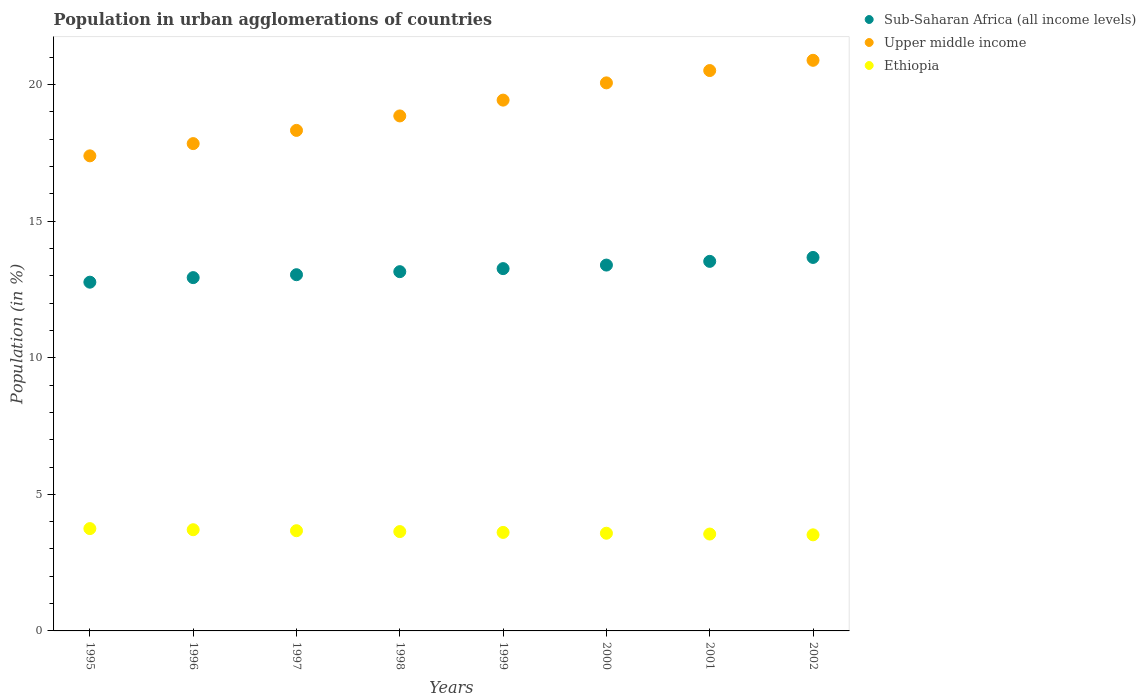What is the percentage of population in urban agglomerations in Ethiopia in 1996?
Make the answer very short. 3.71. Across all years, what is the maximum percentage of population in urban agglomerations in Sub-Saharan Africa (all income levels)?
Give a very brief answer. 13.67. Across all years, what is the minimum percentage of population in urban agglomerations in Ethiopia?
Ensure brevity in your answer.  3.52. In which year was the percentage of population in urban agglomerations in Ethiopia maximum?
Provide a short and direct response. 1995. What is the total percentage of population in urban agglomerations in Ethiopia in the graph?
Give a very brief answer. 29.01. What is the difference between the percentage of population in urban agglomerations in Upper middle income in 1996 and that in 1998?
Offer a very short reply. -1.01. What is the difference between the percentage of population in urban agglomerations in Sub-Saharan Africa (all income levels) in 1995 and the percentage of population in urban agglomerations in Ethiopia in 2001?
Give a very brief answer. 9.22. What is the average percentage of population in urban agglomerations in Sub-Saharan Africa (all income levels) per year?
Your response must be concise. 13.22. In the year 2000, what is the difference between the percentage of population in urban agglomerations in Ethiopia and percentage of population in urban agglomerations in Upper middle income?
Give a very brief answer. -16.49. In how many years, is the percentage of population in urban agglomerations in Ethiopia greater than 14 %?
Keep it short and to the point. 0. What is the ratio of the percentage of population in urban agglomerations in Upper middle income in 1995 to that in 2000?
Make the answer very short. 0.87. Is the difference between the percentage of population in urban agglomerations in Ethiopia in 1995 and 1999 greater than the difference between the percentage of population in urban agglomerations in Upper middle income in 1995 and 1999?
Ensure brevity in your answer.  Yes. What is the difference between the highest and the second highest percentage of population in urban agglomerations in Sub-Saharan Africa (all income levels)?
Make the answer very short. 0.14. What is the difference between the highest and the lowest percentage of population in urban agglomerations in Ethiopia?
Offer a terse response. 0.23. Is the sum of the percentage of population in urban agglomerations in Ethiopia in 1998 and 2000 greater than the maximum percentage of population in urban agglomerations in Upper middle income across all years?
Keep it short and to the point. No. Is it the case that in every year, the sum of the percentage of population in urban agglomerations in Ethiopia and percentage of population in urban agglomerations in Sub-Saharan Africa (all income levels)  is greater than the percentage of population in urban agglomerations in Upper middle income?
Keep it short and to the point. No. Is the percentage of population in urban agglomerations in Ethiopia strictly less than the percentage of population in urban agglomerations in Sub-Saharan Africa (all income levels) over the years?
Your response must be concise. Yes. How many dotlines are there?
Your response must be concise. 3. What is the difference between two consecutive major ticks on the Y-axis?
Provide a succinct answer. 5. Are the values on the major ticks of Y-axis written in scientific E-notation?
Your answer should be very brief. No. Does the graph contain any zero values?
Offer a terse response. No. How many legend labels are there?
Offer a terse response. 3. How are the legend labels stacked?
Your response must be concise. Vertical. What is the title of the graph?
Provide a succinct answer. Population in urban agglomerations of countries. What is the label or title of the Y-axis?
Keep it short and to the point. Population (in %). What is the Population (in %) in Sub-Saharan Africa (all income levels) in 1995?
Give a very brief answer. 12.77. What is the Population (in %) of Upper middle income in 1995?
Your response must be concise. 17.39. What is the Population (in %) of Ethiopia in 1995?
Offer a terse response. 3.75. What is the Population (in %) of Sub-Saharan Africa (all income levels) in 1996?
Provide a succinct answer. 12.94. What is the Population (in %) in Upper middle income in 1996?
Ensure brevity in your answer.  17.84. What is the Population (in %) of Ethiopia in 1996?
Your response must be concise. 3.71. What is the Population (in %) of Sub-Saharan Africa (all income levels) in 1997?
Offer a terse response. 13.04. What is the Population (in %) of Upper middle income in 1997?
Offer a terse response. 18.33. What is the Population (in %) of Ethiopia in 1997?
Give a very brief answer. 3.67. What is the Population (in %) in Sub-Saharan Africa (all income levels) in 1998?
Keep it short and to the point. 13.15. What is the Population (in %) in Upper middle income in 1998?
Offer a very short reply. 18.86. What is the Population (in %) in Ethiopia in 1998?
Keep it short and to the point. 3.64. What is the Population (in %) in Sub-Saharan Africa (all income levels) in 1999?
Ensure brevity in your answer.  13.27. What is the Population (in %) of Upper middle income in 1999?
Offer a very short reply. 19.44. What is the Population (in %) in Ethiopia in 1999?
Offer a very short reply. 3.61. What is the Population (in %) of Sub-Saharan Africa (all income levels) in 2000?
Offer a terse response. 13.4. What is the Population (in %) of Upper middle income in 2000?
Make the answer very short. 20.07. What is the Population (in %) of Ethiopia in 2000?
Give a very brief answer. 3.58. What is the Population (in %) of Sub-Saharan Africa (all income levels) in 2001?
Offer a terse response. 13.53. What is the Population (in %) of Upper middle income in 2001?
Offer a very short reply. 20.52. What is the Population (in %) of Ethiopia in 2001?
Keep it short and to the point. 3.55. What is the Population (in %) in Sub-Saharan Africa (all income levels) in 2002?
Give a very brief answer. 13.67. What is the Population (in %) of Upper middle income in 2002?
Your response must be concise. 20.89. What is the Population (in %) in Ethiopia in 2002?
Ensure brevity in your answer.  3.52. Across all years, what is the maximum Population (in %) of Sub-Saharan Africa (all income levels)?
Your response must be concise. 13.67. Across all years, what is the maximum Population (in %) of Upper middle income?
Your answer should be very brief. 20.89. Across all years, what is the maximum Population (in %) in Ethiopia?
Make the answer very short. 3.75. Across all years, what is the minimum Population (in %) in Sub-Saharan Africa (all income levels)?
Ensure brevity in your answer.  12.77. Across all years, what is the minimum Population (in %) of Upper middle income?
Your answer should be very brief. 17.39. Across all years, what is the minimum Population (in %) of Ethiopia?
Offer a terse response. 3.52. What is the total Population (in %) in Sub-Saharan Africa (all income levels) in the graph?
Provide a short and direct response. 105.77. What is the total Population (in %) in Upper middle income in the graph?
Offer a very short reply. 153.33. What is the total Population (in %) in Ethiopia in the graph?
Provide a succinct answer. 29.01. What is the difference between the Population (in %) of Sub-Saharan Africa (all income levels) in 1995 and that in 1996?
Ensure brevity in your answer.  -0.17. What is the difference between the Population (in %) of Upper middle income in 1995 and that in 1996?
Offer a terse response. -0.45. What is the difference between the Population (in %) of Ethiopia in 1995 and that in 1996?
Provide a succinct answer. 0.04. What is the difference between the Population (in %) in Sub-Saharan Africa (all income levels) in 1995 and that in 1997?
Your answer should be compact. -0.27. What is the difference between the Population (in %) in Upper middle income in 1995 and that in 1997?
Make the answer very short. -0.93. What is the difference between the Population (in %) in Ethiopia in 1995 and that in 1997?
Ensure brevity in your answer.  0.08. What is the difference between the Population (in %) of Sub-Saharan Africa (all income levels) in 1995 and that in 1998?
Your response must be concise. -0.38. What is the difference between the Population (in %) of Upper middle income in 1995 and that in 1998?
Keep it short and to the point. -1.46. What is the difference between the Population (in %) of Ethiopia in 1995 and that in 1998?
Offer a very short reply. 0.11. What is the difference between the Population (in %) in Sub-Saharan Africa (all income levels) in 1995 and that in 1999?
Provide a short and direct response. -0.5. What is the difference between the Population (in %) in Upper middle income in 1995 and that in 1999?
Your response must be concise. -2.04. What is the difference between the Population (in %) in Ethiopia in 1995 and that in 1999?
Offer a very short reply. 0.14. What is the difference between the Population (in %) of Sub-Saharan Africa (all income levels) in 1995 and that in 2000?
Ensure brevity in your answer.  -0.63. What is the difference between the Population (in %) in Upper middle income in 1995 and that in 2000?
Provide a short and direct response. -2.67. What is the difference between the Population (in %) of Ethiopia in 1995 and that in 2000?
Your answer should be very brief. 0.17. What is the difference between the Population (in %) in Sub-Saharan Africa (all income levels) in 1995 and that in 2001?
Ensure brevity in your answer.  -0.76. What is the difference between the Population (in %) in Upper middle income in 1995 and that in 2001?
Your answer should be compact. -3.12. What is the difference between the Population (in %) in Ethiopia in 1995 and that in 2001?
Your response must be concise. 0.2. What is the difference between the Population (in %) of Sub-Saharan Africa (all income levels) in 1995 and that in 2002?
Ensure brevity in your answer.  -0.91. What is the difference between the Population (in %) of Upper middle income in 1995 and that in 2002?
Ensure brevity in your answer.  -3.5. What is the difference between the Population (in %) of Ethiopia in 1995 and that in 2002?
Offer a terse response. 0.23. What is the difference between the Population (in %) in Sub-Saharan Africa (all income levels) in 1996 and that in 1997?
Offer a terse response. -0.11. What is the difference between the Population (in %) in Upper middle income in 1996 and that in 1997?
Offer a terse response. -0.48. What is the difference between the Population (in %) of Ethiopia in 1996 and that in 1997?
Your answer should be compact. 0.04. What is the difference between the Population (in %) of Sub-Saharan Africa (all income levels) in 1996 and that in 1998?
Make the answer very short. -0.22. What is the difference between the Population (in %) of Upper middle income in 1996 and that in 1998?
Your answer should be compact. -1.01. What is the difference between the Population (in %) in Ethiopia in 1996 and that in 1998?
Make the answer very short. 0.07. What is the difference between the Population (in %) in Sub-Saharan Africa (all income levels) in 1996 and that in 1999?
Offer a terse response. -0.33. What is the difference between the Population (in %) of Upper middle income in 1996 and that in 1999?
Offer a terse response. -1.59. What is the difference between the Population (in %) of Ethiopia in 1996 and that in 1999?
Your answer should be compact. 0.1. What is the difference between the Population (in %) in Sub-Saharan Africa (all income levels) in 1996 and that in 2000?
Ensure brevity in your answer.  -0.46. What is the difference between the Population (in %) in Upper middle income in 1996 and that in 2000?
Make the answer very short. -2.22. What is the difference between the Population (in %) of Ethiopia in 1996 and that in 2000?
Your answer should be compact. 0.13. What is the difference between the Population (in %) of Sub-Saharan Africa (all income levels) in 1996 and that in 2001?
Your response must be concise. -0.6. What is the difference between the Population (in %) in Upper middle income in 1996 and that in 2001?
Your answer should be compact. -2.67. What is the difference between the Population (in %) in Ethiopia in 1996 and that in 2001?
Give a very brief answer. 0.16. What is the difference between the Population (in %) in Sub-Saharan Africa (all income levels) in 1996 and that in 2002?
Ensure brevity in your answer.  -0.74. What is the difference between the Population (in %) of Upper middle income in 1996 and that in 2002?
Ensure brevity in your answer.  -3.05. What is the difference between the Population (in %) in Ethiopia in 1996 and that in 2002?
Your response must be concise. 0.19. What is the difference between the Population (in %) in Sub-Saharan Africa (all income levels) in 1997 and that in 1998?
Your answer should be compact. -0.11. What is the difference between the Population (in %) in Upper middle income in 1997 and that in 1998?
Keep it short and to the point. -0.53. What is the difference between the Population (in %) of Ethiopia in 1997 and that in 1998?
Offer a very short reply. 0.03. What is the difference between the Population (in %) in Sub-Saharan Africa (all income levels) in 1997 and that in 1999?
Ensure brevity in your answer.  -0.22. What is the difference between the Population (in %) of Upper middle income in 1997 and that in 1999?
Make the answer very short. -1.11. What is the difference between the Population (in %) in Ethiopia in 1997 and that in 1999?
Ensure brevity in your answer.  0.06. What is the difference between the Population (in %) in Sub-Saharan Africa (all income levels) in 1997 and that in 2000?
Offer a very short reply. -0.35. What is the difference between the Population (in %) in Upper middle income in 1997 and that in 2000?
Your answer should be compact. -1.74. What is the difference between the Population (in %) of Ethiopia in 1997 and that in 2000?
Ensure brevity in your answer.  0.09. What is the difference between the Population (in %) in Sub-Saharan Africa (all income levels) in 1997 and that in 2001?
Offer a very short reply. -0.49. What is the difference between the Population (in %) of Upper middle income in 1997 and that in 2001?
Make the answer very short. -2.19. What is the difference between the Population (in %) of Ethiopia in 1997 and that in 2001?
Offer a very short reply. 0.12. What is the difference between the Population (in %) of Sub-Saharan Africa (all income levels) in 1997 and that in 2002?
Ensure brevity in your answer.  -0.63. What is the difference between the Population (in %) in Upper middle income in 1997 and that in 2002?
Offer a very short reply. -2.57. What is the difference between the Population (in %) in Ethiopia in 1997 and that in 2002?
Give a very brief answer. 0.15. What is the difference between the Population (in %) in Sub-Saharan Africa (all income levels) in 1998 and that in 1999?
Offer a terse response. -0.11. What is the difference between the Population (in %) of Upper middle income in 1998 and that in 1999?
Provide a short and direct response. -0.58. What is the difference between the Population (in %) in Ethiopia in 1998 and that in 1999?
Give a very brief answer. 0.03. What is the difference between the Population (in %) in Sub-Saharan Africa (all income levels) in 1998 and that in 2000?
Offer a terse response. -0.24. What is the difference between the Population (in %) of Upper middle income in 1998 and that in 2000?
Give a very brief answer. -1.21. What is the difference between the Population (in %) in Ethiopia in 1998 and that in 2000?
Provide a short and direct response. 0.06. What is the difference between the Population (in %) of Sub-Saharan Africa (all income levels) in 1998 and that in 2001?
Your response must be concise. -0.38. What is the difference between the Population (in %) in Upper middle income in 1998 and that in 2001?
Offer a terse response. -1.66. What is the difference between the Population (in %) of Ethiopia in 1998 and that in 2001?
Offer a terse response. 0.09. What is the difference between the Population (in %) of Sub-Saharan Africa (all income levels) in 1998 and that in 2002?
Give a very brief answer. -0.52. What is the difference between the Population (in %) of Upper middle income in 1998 and that in 2002?
Provide a short and direct response. -2.04. What is the difference between the Population (in %) of Ethiopia in 1998 and that in 2002?
Offer a very short reply. 0.12. What is the difference between the Population (in %) in Sub-Saharan Africa (all income levels) in 1999 and that in 2000?
Provide a short and direct response. -0.13. What is the difference between the Population (in %) in Upper middle income in 1999 and that in 2000?
Provide a short and direct response. -0.63. What is the difference between the Population (in %) of Ethiopia in 1999 and that in 2000?
Offer a very short reply. 0.03. What is the difference between the Population (in %) in Sub-Saharan Africa (all income levels) in 1999 and that in 2001?
Keep it short and to the point. -0.27. What is the difference between the Population (in %) in Upper middle income in 1999 and that in 2001?
Keep it short and to the point. -1.08. What is the difference between the Population (in %) of Ethiopia in 1999 and that in 2001?
Ensure brevity in your answer.  0.06. What is the difference between the Population (in %) of Sub-Saharan Africa (all income levels) in 1999 and that in 2002?
Keep it short and to the point. -0.41. What is the difference between the Population (in %) in Upper middle income in 1999 and that in 2002?
Your response must be concise. -1.46. What is the difference between the Population (in %) in Ethiopia in 1999 and that in 2002?
Give a very brief answer. 0.09. What is the difference between the Population (in %) of Sub-Saharan Africa (all income levels) in 2000 and that in 2001?
Your response must be concise. -0.14. What is the difference between the Population (in %) in Upper middle income in 2000 and that in 2001?
Provide a short and direct response. -0.45. What is the difference between the Population (in %) in Ethiopia in 2000 and that in 2001?
Ensure brevity in your answer.  0.03. What is the difference between the Population (in %) of Sub-Saharan Africa (all income levels) in 2000 and that in 2002?
Your response must be concise. -0.28. What is the difference between the Population (in %) in Upper middle income in 2000 and that in 2002?
Your answer should be very brief. -0.83. What is the difference between the Population (in %) of Ethiopia in 2000 and that in 2002?
Offer a terse response. 0.06. What is the difference between the Population (in %) of Sub-Saharan Africa (all income levels) in 2001 and that in 2002?
Give a very brief answer. -0.14. What is the difference between the Population (in %) in Upper middle income in 2001 and that in 2002?
Offer a terse response. -0.38. What is the difference between the Population (in %) of Ethiopia in 2001 and that in 2002?
Make the answer very short. 0.03. What is the difference between the Population (in %) in Sub-Saharan Africa (all income levels) in 1995 and the Population (in %) in Upper middle income in 1996?
Make the answer very short. -5.07. What is the difference between the Population (in %) of Sub-Saharan Africa (all income levels) in 1995 and the Population (in %) of Ethiopia in 1996?
Your answer should be very brief. 9.06. What is the difference between the Population (in %) in Upper middle income in 1995 and the Population (in %) in Ethiopia in 1996?
Offer a terse response. 13.69. What is the difference between the Population (in %) of Sub-Saharan Africa (all income levels) in 1995 and the Population (in %) of Upper middle income in 1997?
Your response must be concise. -5.56. What is the difference between the Population (in %) of Sub-Saharan Africa (all income levels) in 1995 and the Population (in %) of Ethiopia in 1997?
Ensure brevity in your answer.  9.1. What is the difference between the Population (in %) in Upper middle income in 1995 and the Population (in %) in Ethiopia in 1997?
Give a very brief answer. 13.73. What is the difference between the Population (in %) of Sub-Saharan Africa (all income levels) in 1995 and the Population (in %) of Upper middle income in 1998?
Your answer should be very brief. -6.09. What is the difference between the Population (in %) in Sub-Saharan Africa (all income levels) in 1995 and the Population (in %) in Ethiopia in 1998?
Make the answer very short. 9.13. What is the difference between the Population (in %) of Upper middle income in 1995 and the Population (in %) of Ethiopia in 1998?
Your answer should be compact. 13.76. What is the difference between the Population (in %) of Sub-Saharan Africa (all income levels) in 1995 and the Population (in %) of Upper middle income in 1999?
Your answer should be compact. -6.67. What is the difference between the Population (in %) in Sub-Saharan Africa (all income levels) in 1995 and the Population (in %) in Ethiopia in 1999?
Give a very brief answer. 9.16. What is the difference between the Population (in %) in Upper middle income in 1995 and the Population (in %) in Ethiopia in 1999?
Provide a succinct answer. 13.79. What is the difference between the Population (in %) in Sub-Saharan Africa (all income levels) in 1995 and the Population (in %) in Upper middle income in 2000?
Keep it short and to the point. -7.3. What is the difference between the Population (in %) of Sub-Saharan Africa (all income levels) in 1995 and the Population (in %) of Ethiopia in 2000?
Give a very brief answer. 9.19. What is the difference between the Population (in %) of Upper middle income in 1995 and the Population (in %) of Ethiopia in 2000?
Your answer should be very brief. 13.82. What is the difference between the Population (in %) in Sub-Saharan Africa (all income levels) in 1995 and the Population (in %) in Upper middle income in 2001?
Your answer should be compact. -7.75. What is the difference between the Population (in %) of Sub-Saharan Africa (all income levels) in 1995 and the Population (in %) of Ethiopia in 2001?
Keep it short and to the point. 9.22. What is the difference between the Population (in %) in Upper middle income in 1995 and the Population (in %) in Ethiopia in 2001?
Make the answer very short. 13.85. What is the difference between the Population (in %) of Sub-Saharan Africa (all income levels) in 1995 and the Population (in %) of Upper middle income in 2002?
Give a very brief answer. -8.12. What is the difference between the Population (in %) in Sub-Saharan Africa (all income levels) in 1995 and the Population (in %) in Ethiopia in 2002?
Your response must be concise. 9.25. What is the difference between the Population (in %) of Upper middle income in 1995 and the Population (in %) of Ethiopia in 2002?
Keep it short and to the point. 13.88. What is the difference between the Population (in %) of Sub-Saharan Africa (all income levels) in 1996 and the Population (in %) of Upper middle income in 1997?
Your answer should be compact. -5.39. What is the difference between the Population (in %) in Sub-Saharan Africa (all income levels) in 1996 and the Population (in %) in Ethiopia in 1997?
Offer a very short reply. 9.27. What is the difference between the Population (in %) in Upper middle income in 1996 and the Population (in %) in Ethiopia in 1997?
Keep it short and to the point. 14.17. What is the difference between the Population (in %) in Sub-Saharan Africa (all income levels) in 1996 and the Population (in %) in Upper middle income in 1998?
Your answer should be compact. -5.92. What is the difference between the Population (in %) of Sub-Saharan Africa (all income levels) in 1996 and the Population (in %) of Ethiopia in 1998?
Give a very brief answer. 9.3. What is the difference between the Population (in %) in Upper middle income in 1996 and the Population (in %) in Ethiopia in 1998?
Your response must be concise. 14.21. What is the difference between the Population (in %) of Sub-Saharan Africa (all income levels) in 1996 and the Population (in %) of Upper middle income in 1999?
Provide a succinct answer. -6.5. What is the difference between the Population (in %) in Sub-Saharan Africa (all income levels) in 1996 and the Population (in %) in Ethiopia in 1999?
Give a very brief answer. 9.33. What is the difference between the Population (in %) in Upper middle income in 1996 and the Population (in %) in Ethiopia in 1999?
Provide a short and direct response. 14.24. What is the difference between the Population (in %) in Sub-Saharan Africa (all income levels) in 1996 and the Population (in %) in Upper middle income in 2000?
Keep it short and to the point. -7.13. What is the difference between the Population (in %) in Sub-Saharan Africa (all income levels) in 1996 and the Population (in %) in Ethiopia in 2000?
Make the answer very short. 9.36. What is the difference between the Population (in %) in Upper middle income in 1996 and the Population (in %) in Ethiopia in 2000?
Provide a succinct answer. 14.27. What is the difference between the Population (in %) in Sub-Saharan Africa (all income levels) in 1996 and the Population (in %) in Upper middle income in 2001?
Offer a very short reply. -7.58. What is the difference between the Population (in %) of Sub-Saharan Africa (all income levels) in 1996 and the Population (in %) of Ethiopia in 2001?
Offer a very short reply. 9.39. What is the difference between the Population (in %) of Upper middle income in 1996 and the Population (in %) of Ethiopia in 2001?
Give a very brief answer. 14.3. What is the difference between the Population (in %) in Sub-Saharan Africa (all income levels) in 1996 and the Population (in %) in Upper middle income in 2002?
Offer a very short reply. -7.96. What is the difference between the Population (in %) in Sub-Saharan Africa (all income levels) in 1996 and the Population (in %) in Ethiopia in 2002?
Provide a short and direct response. 9.42. What is the difference between the Population (in %) of Upper middle income in 1996 and the Population (in %) of Ethiopia in 2002?
Keep it short and to the point. 14.32. What is the difference between the Population (in %) of Sub-Saharan Africa (all income levels) in 1997 and the Population (in %) of Upper middle income in 1998?
Make the answer very short. -5.81. What is the difference between the Population (in %) in Sub-Saharan Africa (all income levels) in 1997 and the Population (in %) in Ethiopia in 1998?
Offer a very short reply. 9.41. What is the difference between the Population (in %) in Upper middle income in 1997 and the Population (in %) in Ethiopia in 1998?
Ensure brevity in your answer.  14.69. What is the difference between the Population (in %) of Sub-Saharan Africa (all income levels) in 1997 and the Population (in %) of Upper middle income in 1999?
Provide a succinct answer. -6.39. What is the difference between the Population (in %) of Sub-Saharan Africa (all income levels) in 1997 and the Population (in %) of Ethiopia in 1999?
Offer a very short reply. 9.44. What is the difference between the Population (in %) of Upper middle income in 1997 and the Population (in %) of Ethiopia in 1999?
Ensure brevity in your answer.  14.72. What is the difference between the Population (in %) of Sub-Saharan Africa (all income levels) in 1997 and the Population (in %) of Upper middle income in 2000?
Your answer should be very brief. -7.02. What is the difference between the Population (in %) in Sub-Saharan Africa (all income levels) in 1997 and the Population (in %) in Ethiopia in 2000?
Offer a terse response. 9.47. What is the difference between the Population (in %) in Upper middle income in 1997 and the Population (in %) in Ethiopia in 2000?
Provide a succinct answer. 14.75. What is the difference between the Population (in %) in Sub-Saharan Africa (all income levels) in 1997 and the Population (in %) in Upper middle income in 2001?
Your answer should be compact. -7.48. What is the difference between the Population (in %) in Sub-Saharan Africa (all income levels) in 1997 and the Population (in %) in Ethiopia in 2001?
Offer a terse response. 9.5. What is the difference between the Population (in %) of Upper middle income in 1997 and the Population (in %) of Ethiopia in 2001?
Ensure brevity in your answer.  14.78. What is the difference between the Population (in %) in Sub-Saharan Africa (all income levels) in 1997 and the Population (in %) in Upper middle income in 2002?
Provide a succinct answer. -7.85. What is the difference between the Population (in %) of Sub-Saharan Africa (all income levels) in 1997 and the Population (in %) of Ethiopia in 2002?
Provide a short and direct response. 9.52. What is the difference between the Population (in %) of Upper middle income in 1997 and the Population (in %) of Ethiopia in 2002?
Keep it short and to the point. 14.81. What is the difference between the Population (in %) in Sub-Saharan Africa (all income levels) in 1998 and the Population (in %) in Upper middle income in 1999?
Keep it short and to the point. -6.28. What is the difference between the Population (in %) in Sub-Saharan Africa (all income levels) in 1998 and the Population (in %) in Ethiopia in 1999?
Provide a succinct answer. 9.55. What is the difference between the Population (in %) of Upper middle income in 1998 and the Population (in %) of Ethiopia in 1999?
Make the answer very short. 15.25. What is the difference between the Population (in %) of Sub-Saharan Africa (all income levels) in 1998 and the Population (in %) of Upper middle income in 2000?
Your response must be concise. -6.91. What is the difference between the Population (in %) in Sub-Saharan Africa (all income levels) in 1998 and the Population (in %) in Ethiopia in 2000?
Your answer should be very brief. 9.58. What is the difference between the Population (in %) in Upper middle income in 1998 and the Population (in %) in Ethiopia in 2000?
Offer a very short reply. 15.28. What is the difference between the Population (in %) in Sub-Saharan Africa (all income levels) in 1998 and the Population (in %) in Upper middle income in 2001?
Make the answer very short. -7.36. What is the difference between the Population (in %) in Sub-Saharan Africa (all income levels) in 1998 and the Population (in %) in Ethiopia in 2001?
Make the answer very short. 9.61. What is the difference between the Population (in %) in Upper middle income in 1998 and the Population (in %) in Ethiopia in 2001?
Make the answer very short. 15.31. What is the difference between the Population (in %) in Sub-Saharan Africa (all income levels) in 1998 and the Population (in %) in Upper middle income in 2002?
Your answer should be compact. -7.74. What is the difference between the Population (in %) in Sub-Saharan Africa (all income levels) in 1998 and the Population (in %) in Ethiopia in 2002?
Your answer should be compact. 9.64. What is the difference between the Population (in %) of Upper middle income in 1998 and the Population (in %) of Ethiopia in 2002?
Your response must be concise. 15.34. What is the difference between the Population (in %) in Sub-Saharan Africa (all income levels) in 1999 and the Population (in %) in Upper middle income in 2000?
Ensure brevity in your answer.  -6.8. What is the difference between the Population (in %) of Sub-Saharan Africa (all income levels) in 1999 and the Population (in %) of Ethiopia in 2000?
Make the answer very short. 9.69. What is the difference between the Population (in %) in Upper middle income in 1999 and the Population (in %) in Ethiopia in 2000?
Your response must be concise. 15.86. What is the difference between the Population (in %) in Sub-Saharan Africa (all income levels) in 1999 and the Population (in %) in Upper middle income in 2001?
Offer a very short reply. -7.25. What is the difference between the Population (in %) of Sub-Saharan Africa (all income levels) in 1999 and the Population (in %) of Ethiopia in 2001?
Your response must be concise. 9.72. What is the difference between the Population (in %) of Upper middle income in 1999 and the Population (in %) of Ethiopia in 2001?
Ensure brevity in your answer.  15.89. What is the difference between the Population (in %) of Sub-Saharan Africa (all income levels) in 1999 and the Population (in %) of Upper middle income in 2002?
Your answer should be very brief. -7.63. What is the difference between the Population (in %) in Sub-Saharan Africa (all income levels) in 1999 and the Population (in %) in Ethiopia in 2002?
Provide a short and direct response. 9.75. What is the difference between the Population (in %) of Upper middle income in 1999 and the Population (in %) of Ethiopia in 2002?
Provide a short and direct response. 15.92. What is the difference between the Population (in %) of Sub-Saharan Africa (all income levels) in 2000 and the Population (in %) of Upper middle income in 2001?
Your answer should be very brief. -7.12. What is the difference between the Population (in %) of Sub-Saharan Africa (all income levels) in 2000 and the Population (in %) of Ethiopia in 2001?
Offer a very short reply. 9.85. What is the difference between the Population (in %) in Upper middle income in 2000 and the Population (in %) in Ethiopia in 2001?
Keep it short and to the point. 16.52. What is the difference between the Population (in %) in Sub-Saharan Africa (all income levels) in 2000 and the Population (in %) in Upper middle income in 2002?
Provide a succinct answer. -7.5. What is the difference between the Population (in %) in Sub-Saharan Africa (all income levels) in 2000 and the Population (in %) in Ethiopia in 2002?
Provide a short and direct response. 9.88. What is the difference between the Population (in %) of Upper middle income in 2000 and the Population (in %) of Ethiopia in 2002?
Offer a terse response. 16.55. What is the difference between the Population (in %) of Sub-Saharan Africa (all income levels) in 2001 and the Population (in %) of Upper middle income in 2002?
Your answer should be very brief. -7.36. What is the difference between the Population (in %) of Sub-Saharan Africa (all income levels) in 2001 and the Population (in %) of Ethiopia in 2002?
Your response must be concise. 10.01. What is the difference between the Population (in %) of Upper middle income in 2001 and the Population (in %) of Ethiopia in 2002?
Offer a very short reply. 17. What is the average Population (in %) of Sub-Saharan Africa (all income levels) per year?
Offer a very short reply. 13.22. What is the average Population (in %) of Upper middle income per year?
Ensure brevity in your answer.  19.17. What is the average Population (in %) of Ethiopia per year?
Ensure brevity in your answer.  3.63. In the year 1995, what is the difference between the Population (in %) in Sub-Saharan Africa (all income levels) and Population (in %) in Upper middle income?
Your answer should be compact. -4.63. In the year 1995, what is the difference between the Population (in %) of Sub-Saharan Africa (all income levels) and Population (in %) of Ethiopia?
Make the answer very short. 9.02. In the year 1995, what is the difference between the Population (in %) of Upper middle income and Population (in %) of Ethiopia?
Keep it short and to the point. 13.65. In the year 1996, what is the difference between the Population (in %) of Sub-Saharan Africa (all income levels) and Population (in %) of Upper middle income?
Your answer should be compact. -4.91. In the year 1996, what is the difference between the Population (in %) in Sub-Saharan Africa (all income levels) and Population (in %) in Ethiopia?
Keep it short and to the point. 9.23. In the year 1996, what is the difference between the Population (in %) of Upper middle income and Population (in %) of Ethiopia?
Give a very brief answer. 14.14. In the year 1997, what is the difference between the Population (in %) in Sub-Saharan Africa (all income levels) and Population (in %) in Upper middle income?
Provide a short and direct response. -5.28. In the year 1997, what is the difference between the Population (in %) of Sub-Saharan Africa (all income levels) and Population (in %) of Ethiopia?
Your response must be concise. 9.37. In the year 1997, what is the difference between the Population (in %) in Upper middle income and Population (in %) in Ethiopia?
Make the answer very short. 14.66. In the year 1998, what is the difference between the Population (in %) of Sub-Saharan Africa (all income levels) and Population (in %) of Upper middle income?
Offer a very short reply. -5.7. In the year 1998, what is the difference between the Population (in %) of Sub-Saharan Africa (all income levels) and Population (in %) of Ethiopia?
Your answer should be compact. 9.52. In the year 1998, what is the difference between the Population (in %) in Upper middle income and Population (in %) in Ethiopia?
Provide a short and direct response. 15.22. In the year 1999, what is the difference between the Population (in %) in Sub-Saharan Africa (all income levels) and Population (in %) in Upper middle income?
Your answer should be very brief. -6.17. In the year 1999, what is the difference between the Population (in %) in Sub-Saharan Africa (all income levels) and Population (in %) in Ethiopia?
Give a very brief answer. 9.66. In the year 1999, what is the difference between the Population (in %) in Upper middle income and Population (in %) in Ethiopia?
Your answer should be very brief. 15.83. In the year 2000, what is the difference between the Population (in %) of Sub-Saharan Africa (all income levels) and Population (in %) of Upper middle income?
Keep it short and to the point. -6.67. In the year 2000, what is the difference between the Population (in %) of Sub-Saharan Africa (all income levels) and Population (in %) of Ethiopia?
Your response must be concise. 9.82. In the year 2000, what is the difference between the Population (in %) in Upper middle income and Population (in %) in Ethiopia?
Your response must be concise. 16.49. In the year 2001, what is the difference between the Population (in %) of Sub-Saharan Africa (all income levels) and Population (in %) of Upper middle income?
Offer a very short reply. -6.99. In the year 2001, what is the difference between the Population (in %) in Sub-Saharan Africa (all income levels) and Population (in %) in Ethiopia?
Ensure brevity in your answer.  9.98. In the year 2001, what is the difference between the Population (in %) in Upper middle income and Population (in %) in Ethiopia?
Make the answer very short. 16.97. In the year 2002, what is the difference between the Population (in %) in Sub-Saharan Africa (all income levels) and Population (in %) in Upper middle income?
Make the answer very short. -7.22. In the year 2002, what is the difference between the Population (in %) in Sub-Saharan Africa (all income levels) and Population (in %) in Ethiopia?
Ensure brevity in your answer.  10.16. In the year 2002, what is the difference between the Population (in %) in Upper middle income and Population (in %) in Ethiopia?
Ensure brevity in your answer.  17.37. What is the ratio of the Population (in %) of Sub-Saharan Africa (all income levels) in 1995 to that in 1996?
Your answer should be very brief. 0.99. What is the ratio of the Population (in %) of Upper middle income in 1995 to that in 1996?
Your answer should be very brief. 0.97. What is the ratio of the Population (in %) in Ethiopia in 1995 to that in 1996?
Provide a short and direct response. 1.01. What is the ratio of the Population (in %) of Upper middle income in 1995 to that in 1997?
Give a very brief answer. 0.95. What is the ratio of the Population (in %) in Sub-Saharan Africa (all income levels) in 1995 to that in 1998?
Your answer should be very brief. 0.97. What is the ratio of the Population (in %) of Upper middle income in 1995 to that in 1998?
Provide a succinct answer. 0.92. What is the ratio of the Population (in %) of Sub-Saharan Africa (all income levels) in 1995 to that in 1999?
Your answer should be compact. 0.96. What is the ratio of the Population (in %) of Upper middle income in 1995 to that in 1999?
Your answer should be compact. 0.9. What is the ratio of the Population (in %) in Ethiopia in 1995 to that in 1999?
Provide a short and direct response. 1.04. What is the ratio of the Population (in %) of Sub-Saharan Africa (all income levels) in 1995 to that in 2000?
Keep it short and to the point. 0.95. What is the ratio of the Population (in %) in Upper middle income in 1995 to that in 2000?
Ensure brevity in your answer.  0.87. What is the ratio of the Population (in %) of Ethiopia in 1995 to that in 2000?
Ensure brevity in your answer.  1.05. What is the ratio of the Population (in %) in Sub-Saharan Africa (all income levels) in 1995 to that in 2001?
Ensure brevity in your answer.  0.94. What is the ratio of the Population (in %) of Upper middle income in 1995 to that in 2001?
Your response must be concise. 0.85. What is the ratio of the Population (in %) of Ethiopia in 1995 to that in 2001?
Provide a succinct answer. 1.06. What is the ratio of the Population (in %) of Sub-Saharan Africa (all income levels) in 1995 to that in 2002?
Make the answer very short. 0.93. What is the ratio of the Population (in %) of Upper middle income in 1995 to that in 2002?
Provide a short and direct response. 0.83. What is the ratio of the Population (in %) of Ethiopia in 1995 to that in 2002?
Give a very brief answer. 1.06. What is the ratio of the Population (in %) of Upper middle income in 1996 to that in 1997?
Provide a short and direct response. 0.97. What is the ratio of the Population (in %) in Ethiopia in 1996 to that in 1997?
Make the answer very short. 1.01. What is the ratio of the Population (in %) in Sub-Saharan Africa (all income levels) in 1996 to that in 1998?
Provide a short and direct response. 0.98. What is the ratio of the Population (in %) in Upper middle income in 1996 to that in 1998?
Offer a very short reply. 0.95. What is the ratio of the Population (in %) in Ethiopia in 1996 to that in 1998?
Give a very brief answer. 1.02. What is the ratio of the Population (in %) of Sub-Saharan Africa (all income levels) in 1996 to that in 1999?
Your answer should be very brief. 0.98. What is the ratio of the Population (in %) of Upper middle income in 1996 to that in 1999?
Provide a succinct answer. 0.92. What is the ratio of the Population (in %) of Ethiopia in 1996 to that in 1999?
Your response must be concise. 1.03. What is the ratio of the Population (in %) of Sub-Saharan Africa (all income levels) in 1996 to that in 2000?
Provide a succinct answer. 0.97. What is the ratio of the Population (in %) of Upper middle income in 1996 to that in 2000?
Your response must be concise. 0.89. What is the ratio of the Population (in %) of Ethiopia in 1996 to that in 2000?
Keep it short and to the point. 1.04. What is the ratio of the Population (in %) of Sub-Saharan Africa (all income levels) in 1996 to that in 2001?
Your answer should be compact. 0.96. What is the ratio of the Population (in %) of Upper middle income in 1996 to that in 2001?
Your response must be concise. 0.87. What is the ratio of the Population (in %) in Ethiopia in 1996 to that in 2001?
Give a very brief answer. 1.04. What is the ratio of the Population (in %) in Sub-Saharan Africa (all income levels) in 1996 to that in 2002?
Provide a short and direct response. 0.95. What is the ratio of the Population (in %) in Upper middle income in 1996 to that in 2002?
Provide a succinct answer. 0.85. What is the ratio of the Population (in %) of Ethiopia in 1996 to that in 2002?
Your answer should be compact. 1.05. What is the ratio of the Population (in %) in Sub-Saharan Africa (all income levels) in 1997 to that in 1998?
Offer a very short reply. 0.99. What is the ratio of the Population (in %) of Upper middle income in 1997 to that in 1998?
Make the answer very short. 0.97. What is the ratio of the Population (in %) in Ethiopia in 1997 to that in 1998?
Offer a very short reply. 1.01. What is the ratio of the Population (in %) of Sub-Saharan Africa (all income levels) in 1997 to that in 1999?
Your response must be concise. 0.98. What is the ratio of the Population (in %) in Upper middle income in 1997 to that in 1999?
Provide a succinct answer. 0.94. What is the ratio of the Population (in %) in Ethiopia in 1997 to that in 1999?
Provide a short and direct response. 1.02. What is the ratio of the Population (in %) of Sub-Saharan Africa (all income levels) in 1997 to that in 2000?
Provide a succinct answer. 0.97. What is the ratio of the Population (in %) of Upper middle income in 1997 to that in 2000?
Keep it short and to the point. 0.91. What is the ratio of the Population (in %) of Ethiopia in 1997 to that in 2000?
Your answer should be compact. 1.03. What is the ratio of the Population (in %) of Sub-Saharan Africa (all income levels) in 1997 to that in 2001?
Keep it short and to the point. 0.96. What is the ratio of the Population (in %) of Upper middle income in 1997 to that in 2001?
Your answer should be very brief. 0.89. What is the ratio of the Population (in %) in Ethiopia in 1997 to that in 2001?
Offer a very short reply. 1.03. What is the ratio of the Population (in %) of Sub-Saharan Africa (all income levels) in 1997 to that in 2002?
Offer a very short reply. 0.95. What is the ratio of the Population (in %) in Upper middle income in 1997 to that in 2002?
Keep it short and to the point. 0.88. What is the ratio of the Population (in %) in Ethiopia in 1997 to that in 2002?
Make the answer very short. 1.04. What is the ratio of the Population (in %) in Sub-Saharan Africa (all income levels) in 1998 to that in 1999?
Your answer should be compact. 0.99. What is the ratio of the Population (in %) in Upper middle income in 1998 to that in 1999?
Give a very brief answer. 0.97. What is the ratio of the Population (in %) of Ethiopia in 1998 to that in 1999?
Provide a succinct answer. 1.01. What is the ratio of the Population (in %) in Upper middle income in 1998 to that in 2000?
Your response must be concise. 0.94. What is the ratio of the Population (in %) of Ethiopia in 1998 to that in 2000?
Offer a terse response. 1.02. What is the ratio of the Population (in %) in Sub-Saharan Africa (all income levels) in 1998 to that in 2001?
Give a very brief answer. 0.97. What is the ratio of the Population (in %) in Upper middle income in 1998 to that in 2001?
Your answer should be compact. 0.92. What is the ratio of the Population (in %) of Ethiopia in 1998 to that in 2001?
Provide a short and direct response. 1.03. What is the ratio of the Population (in %) of Sub-Saharan Africa (all income levels) in 1998 to that in 2002?
Offer a very short reply. 0.96. What is the ratio of the Population (in %) of Upper middle income in 1998 to that in 2002?
Provide a short and direct response. 0.9. What is the ratio of the Population (in %) of Ethiopia in 1998 to that in 2002?
Ensure brevity in your answer.  1.03. What is the ratio of the Population (in %) of Sub-Saharan Africa (all income levels) in 1999 to that in 2000?
Offer a very short reply. 0.99. What is the ratio of the Population (in %) of Upper middle income in 1999 to that in 2000?
Offer a terse response. 0.97. What is the ratio of the Population (in %) in Ethiopia in 1999 to that in 2000?
Make the answer very short. 1.01. What is the ratio of the Population (in %) of Sub-Saharan Africa (all income levels) in 1999 to that in 2001?
Make the answer very short. 0.98. What is the ratio of the Population (in %) of Upper middle income in 1999 to that in 2001?
Your answer should be compact. 0.95. What is the ratio of the Population (in %) in Ethiopia in 1999 to that in 2001?
Keep it short and to the point. 1.02. What is the ratio of the Population (in %) of Sub-Saharan Africa (all income levels) in 1999 to that in 2002?
Give a very brief answer. 0.97. What is the ratio of the Population (in %) of Upper middle income in 1999 to that in 2002?
Offer a very short reply. 0.93. What is the ratio of the Population (in %) of Ethiopia in 1999 to that in 2002?
Make the answer very short. 1.03. What is the ratio of the Population (in %) of Upper middle income in 2000 to that in 2001?
Offer a very short reply. 0.98. What is the ratio of the Population (in %) of Ethiopia in 2000 to that in 2001?
Make the answer very short. 1.01. What is the ratio of the Population (in %) in Sub-Saharan Africa (all income levels) in 2000 to that in 2002?
Keep it short and to the point. 0.98. What is the ratio of the Population (in %) in Upper middle income in 2000 to that in 2002?
Your answer should be very brief. 0.96. What is the ratio of the Population (in %) of Ethiopia in 2000 to that in 2002?
Give a very brief answer. 1.02. What is the ratio of the Population (in %) of Sub-Saharan Africa (all income levels) in 2001 to that in 2002?
Your answer should be very brief. 0.99. What is the ratio of the Population (in %) in Ethiopia in 2001 to that in 2002?
Provide a succinct answer. 1.01. What is the difference between the highest and the second highest Population (in %) in Sub-Saharan Africa (all income levels)?
Ensure brevity in your answer.  0.14. What is the difference between the highest and the second highest Population (in %) in Upper middle income?
Provide a succinct answer. 0.38. What is the difference between the highest and the second highest Population (in %) of Ethiopia?
Make the answer very short. 0.04. What is the difference between the highest and the lowest Population (in %) in Sub-Saharan Africa (all income levels)?
Your answer should be compact. 0.91. What is the difference between the highest and the lowest Population (in %) in Upper middle income?
Offer a terse response. 3.5. What is the difference between the highest and the lowest Population (in %) in Ethiopia?
Ensure brevity in your answer.  0.23. 